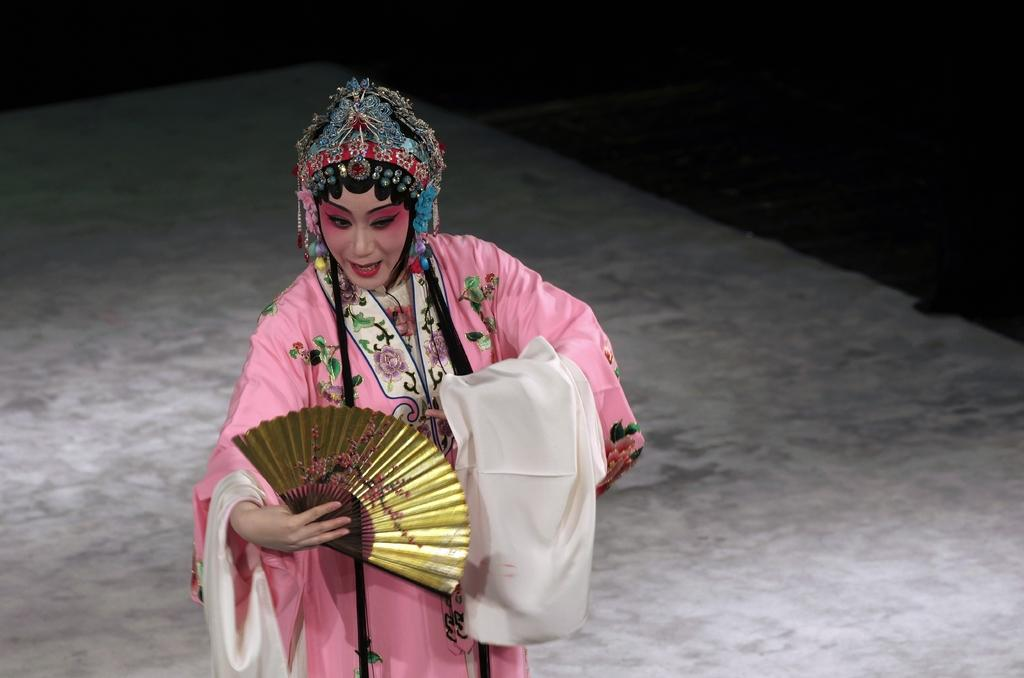What is present in the image? There is a person in the image. Can you describe the person's attire? The person is wearing clothes. What object is the person holding in her hand? The person is holding a fan in her hand. What type of floor is visible in the image? There is a cement floor in the middle of the image. What type of collar can be seen on the hen in the image? There is no hen present in the image, so there is no collar to be seen. 